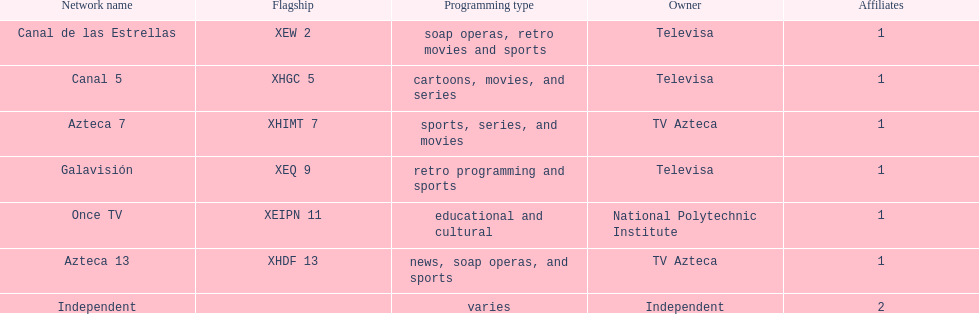Televisa owns how many networks? 3. 